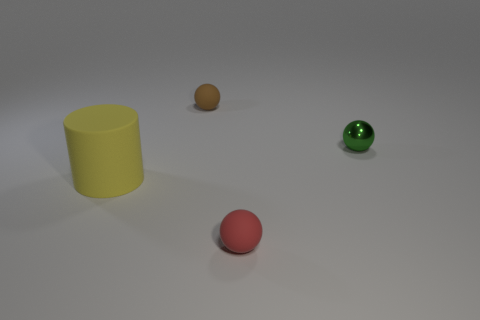There is a small matte object behind the small metal thing; is its shape the same as the matte thing that is right of the tiny brown sphere? Yes, both objects are cylindrical in shape; the small matte object behind the small metal thing and the matte object to the right of the tiny brown sphere share this characteristic form. 